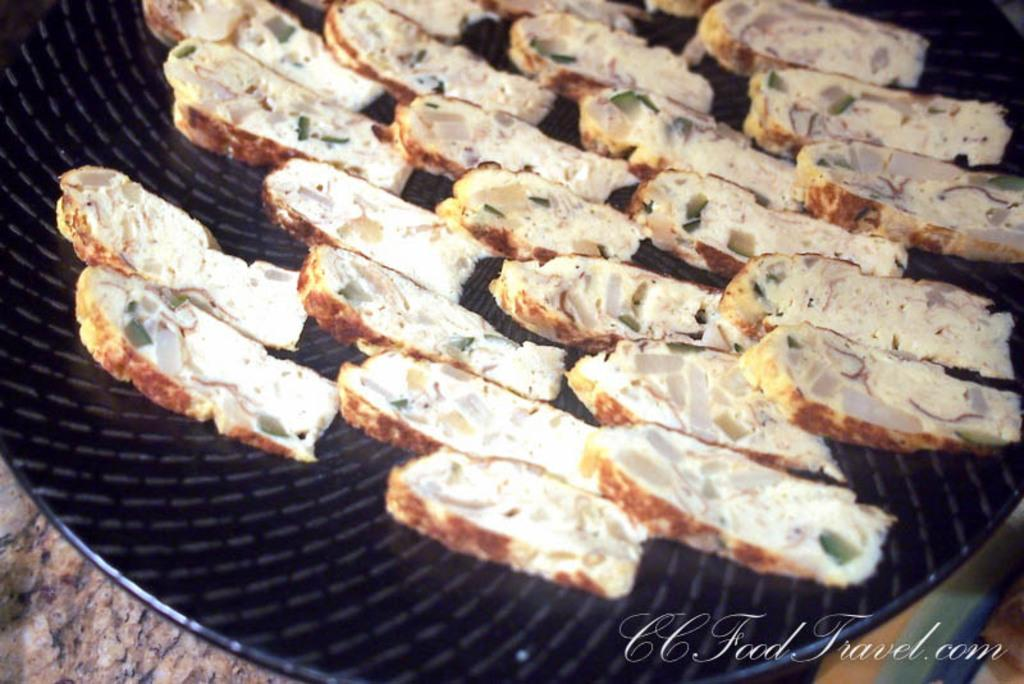What is present on the plate in the image? There are food items in a plate in the image. Can you describe the objects in the bottom corners of the image? There is an object in the bottom left corner and another object in the bottom right corner of the image. How many feet are visible in the image? There are no feet visible in the image. What type of birth is depicted in the image? There is no birth depicted in the image. 